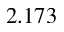<formula> <loc_0><loc_0><loc_500><loc_500>2 . 1 7 3</formula> 